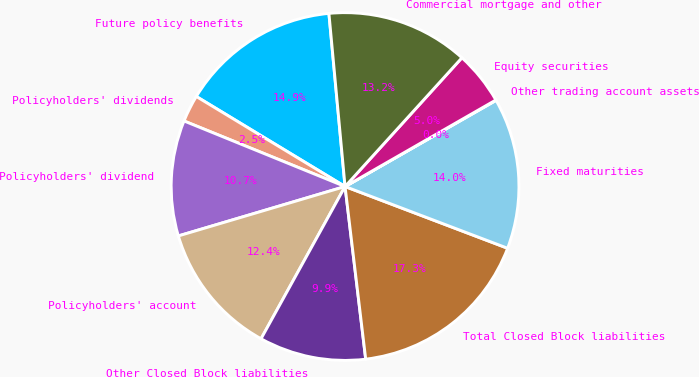Convert chart. <chart><loc_0><loc_0><loc_500><loc_500><pie_chart><fcel>Future policy benefits<fcel>Policyholders' dividends<fcel>Policyholders' dividend<fcel>Policyholders' account<fcel>Other Closed Block liabilities<fcel>Total Closed Block liabilities<fcel>Fixed maturities<fcel>Other trading account assets<fcel>Equity securities<fcel>Commercial mortgage and other<nl><fcel>14.86%<fcel>2.51%<fcel>10.74%<fcel>12.39%<fcel>9.92%<fcel>17.33%<fcel>14.03%<fcel>0.04%<fcel>4.98%<fcel>13.21%<nl></chart> 